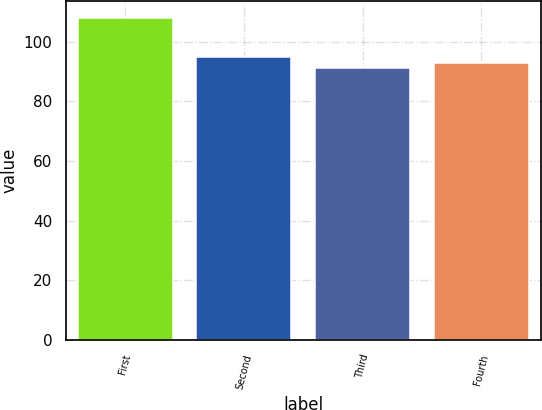Convert chart. <chart><loc_0><loc_0><loc_500><loc_500><bar_chart><fcel>First<fcel>Second<fcel>Third<fcel>Fourth<nl><fcel>108.07<fcel>94.74<fcel>91.02<fcel>92.72<nl></chart> 